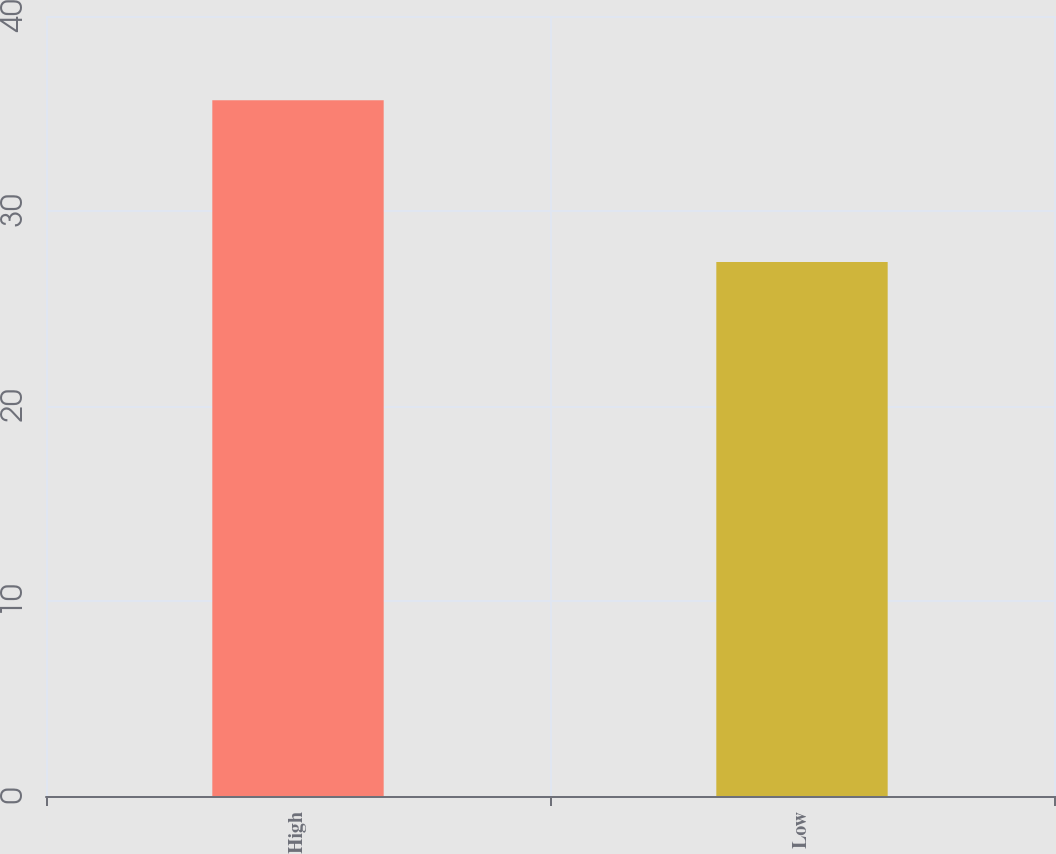Convert chart to OTSL. <chart><loc_0><loc_0><loc_500><loc_500><bar_chart><fcel>High<fcel>Low<nl><fcel>35.68<fcel>27.39<nl></chart> 